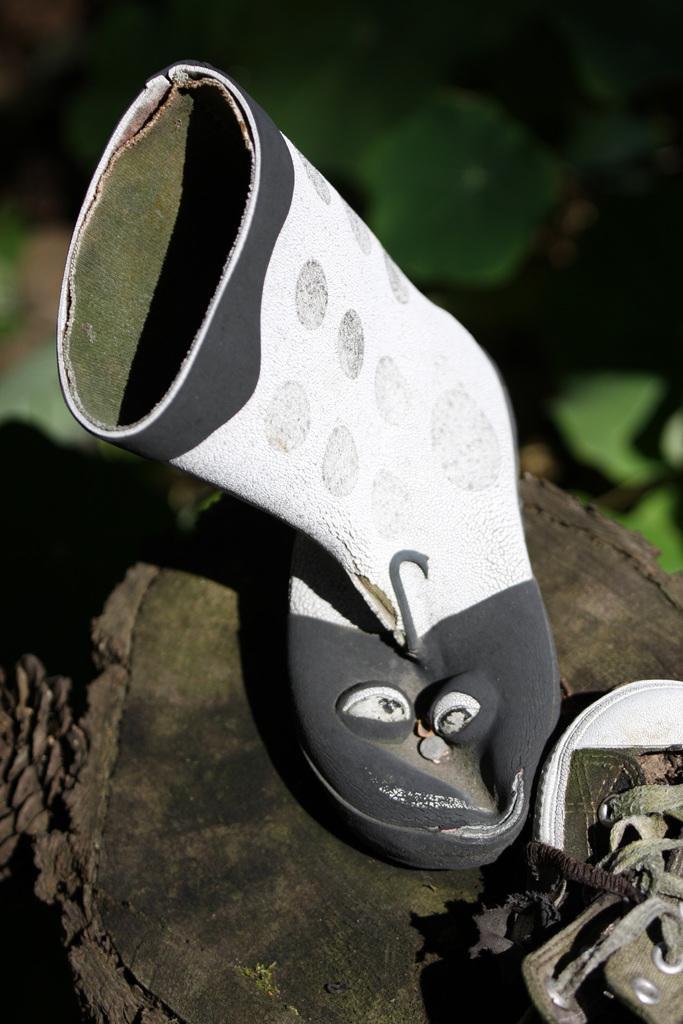In one or two sentences, can you explain what this image depicts? The picture consists of shoes on the trunk of a tree. The background is blurred. In the background there is greenery. 